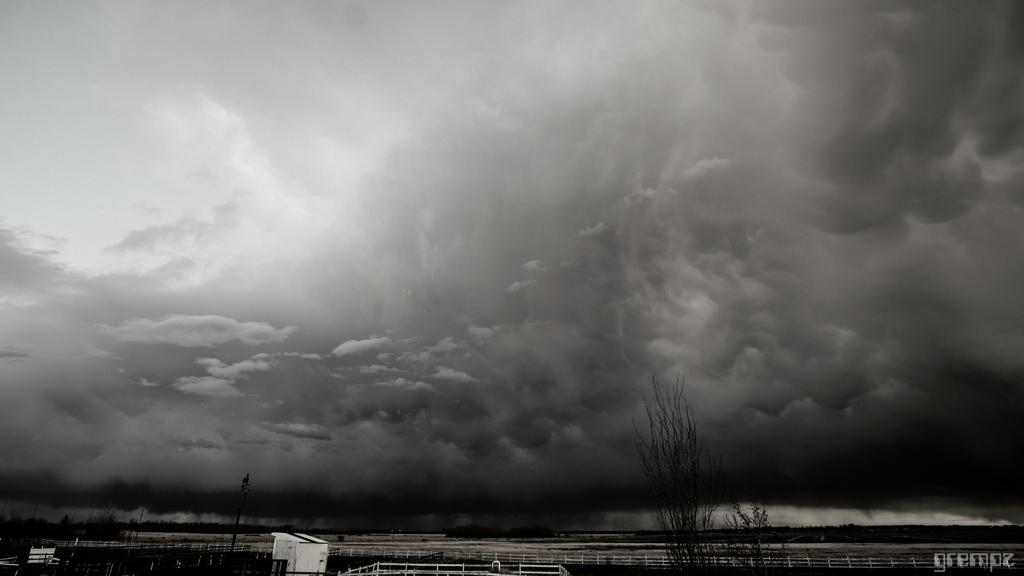What type of vegetation is present at the bottom of the image? There are trees at the bottom of the image. What can be found at the bottom of the image besides trees? There is a walkway, houses, and poles at the bottom of the image. What is visible at the top of the image? The sky is visible at the top of the image. How many crayons are being used by the women in the hall in the image? There are no women or crayons present in the image; it features trees, a walkway, houses, poles, and the sky. 